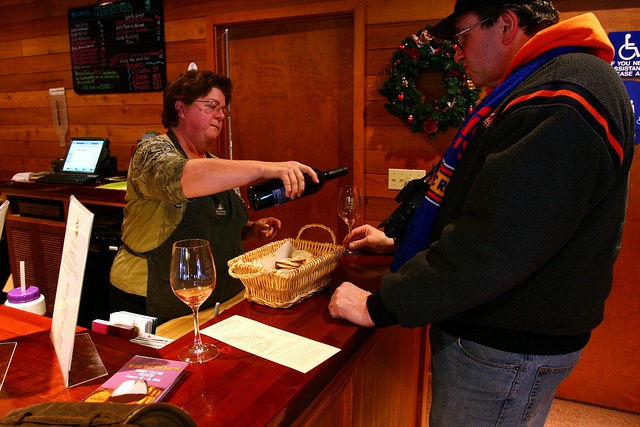Describe the objects in this image and their specific colors. I can see people in maroon, black, brown, and navy tones, people in maroon, black, and brown tones, wine glass in maroon, black, and brown tones, book in maroon, lightpink, and white tones, and laptop in maroon, white, black, lightblue, and gray tones in this image. 